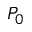<formula> <loc_0><loc_0><loc_500><loc_500>P _ { 0 }</formula> 